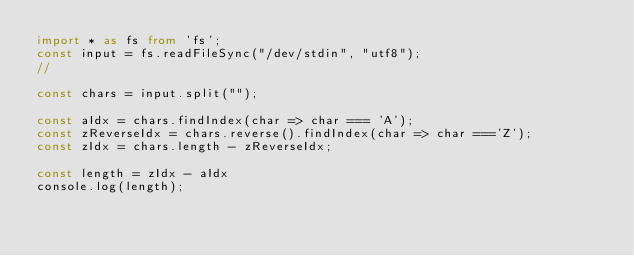Convert code to text. <code><loc_0><loc_0><loc_500><loc_500><_TypeScript_>import * as fs from 'fs';
const input = fs.readFileSync("/dev/stdin", "utf8");
// 

const chars = input.split("");

const aIdx = chars.findIndex(char => char === 'A');
const zReverseIdx = chars.reverse().findIndex(char => char ==='Z');
const zIdx = chars.length - zReverseIdx;

const length = zIdx - aIdx
console.log(length);</code> 